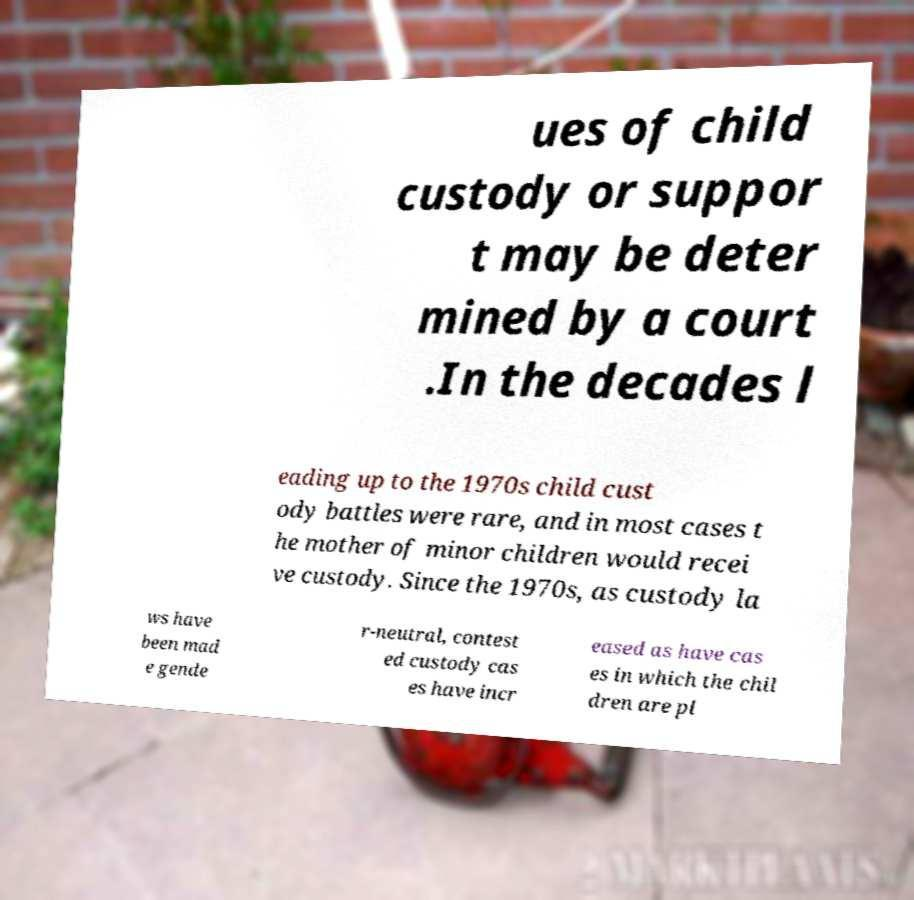Could you extract and type out the text from this image? ues of child custody or suppor t may be deter mined by a court .In the decades l eading up to the 1970s child cust ody battles were rare, and in most cases t he mother of minor children would recei ve custody. Since the 1970s, as custody la ws have been mad e gende r-neutral, contest ed custody cas es have incr eased as have cas es in which the chil dren are pl 